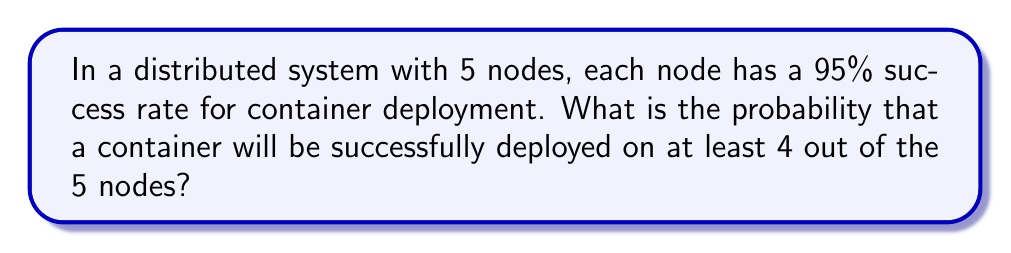Teach me how to tackle this problem. Let's approach this step-by-step:

1) First, we need to calculate the probability of success on exactly 4 nodes and exactly 5 nodes, then sum these probabilities.

2) We can use the binomial probability formula:

   $$P(X = k) = \binom{n}{k} p^k (1-p)^{n-k}$$

   Where:
   $n$ = total number of nodes (5)
   $k$ = number of successful deployments
   $p$ = probability of success on each node (0.95)

3) For exactly 4 successful deployments:

   $$P(X = 4) = \binom{5}{4} (0.95)^4 (0.05)^1$$
   $$= 5 \cdot 0.95^4 \cdot 0.05$$
   $$= 5 \cdot 0.81450625 \cdot 0.05$$
   $$= 0.203626563$$

4) For exactly 5 successful deployments:

   $$P(X = 5) = \binom{5}{5} (0.95)^5 (0.05)^0$$
   $$= 1 \cdot 0.95^5$$
   $$= 0.773780469$$

5) The probability of at least 4 successful deployments is the sum of these two probabilities:

   $$P(X \geq 4) = P(X = 4) + P(X = 5)$$
   $$= 0.203626563 + 0.773780469$$
   $$= 0.977407032$$
Answer: 0.977407032 